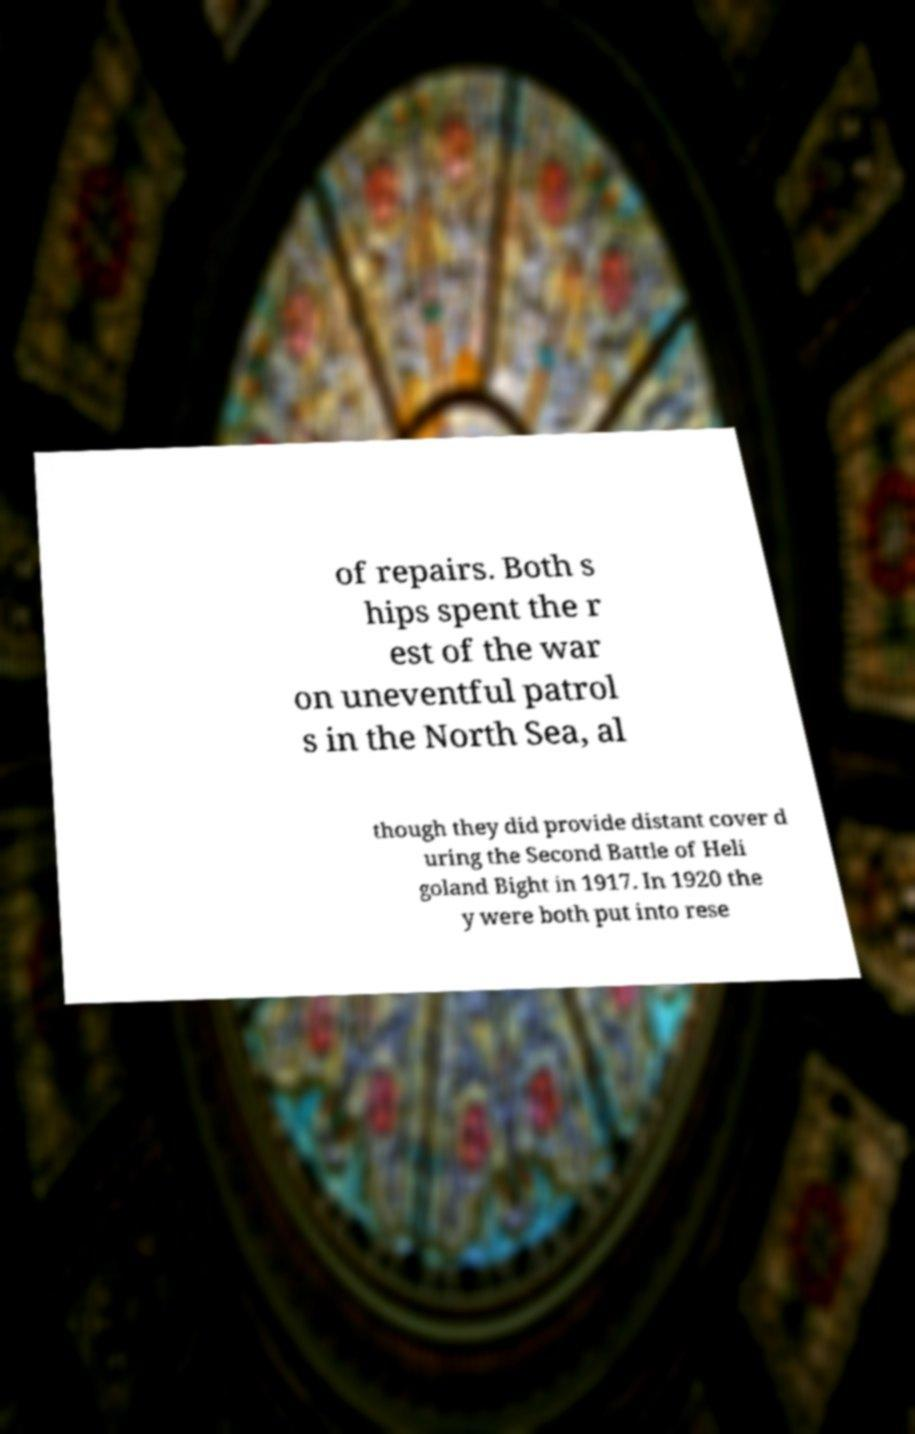Could you assist in decoding the text presented in this image and type it out clearly? of repairs. Both s hips spent the r est of the war on uneventful patrol s in the North Sea, al though they did provide distant cover d uring the Second Battle of Heli goland Bight in 1917. In 1920 the y were both put into rese 